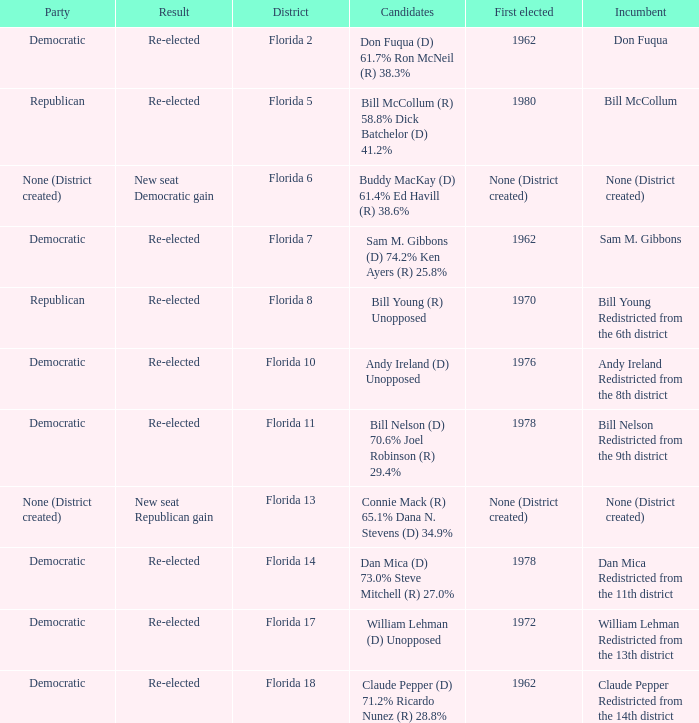 how many candidates with result being new seat democratic gain 1.0. 